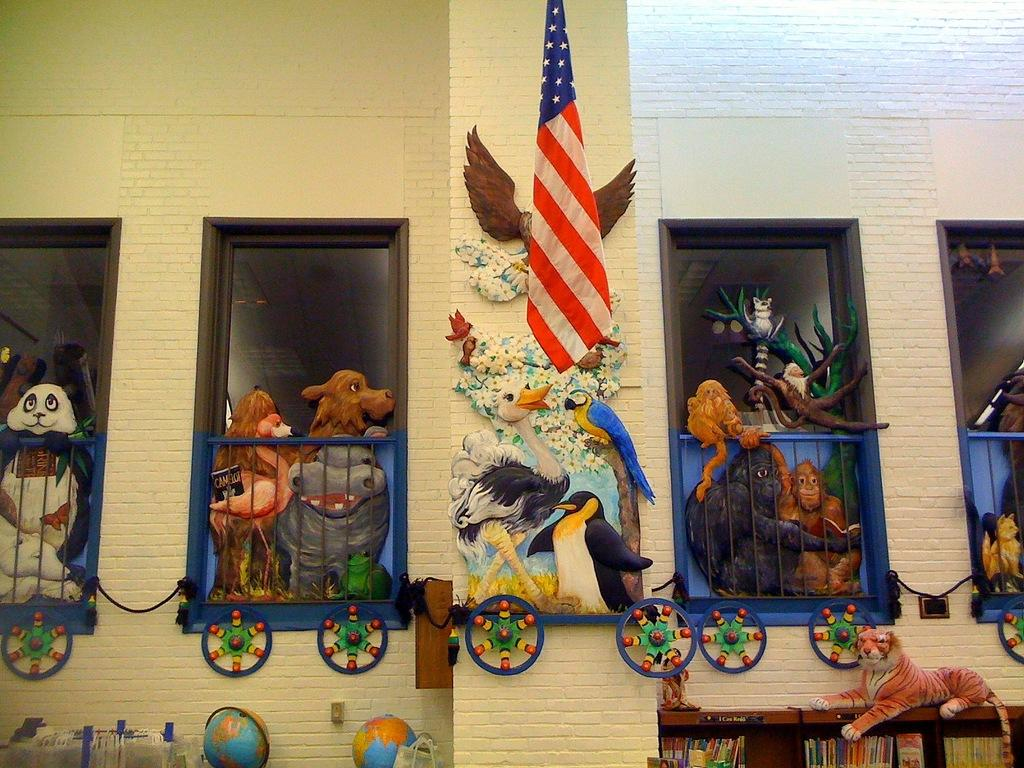What is the main structure in the center of the image? There is a building in the center of the image. What other architectural feature can be seen in the image? There is a wall in the image. What symbol is present in the image? There is a flag in the image. What items related to learning or play can be seen in the image? There are toys, books, and globes in the image. Can you describe any other objects in the image? There are a few other objects in the image. What type of pie is being served on the bed in the image? There is no bed or pie present in the image. 